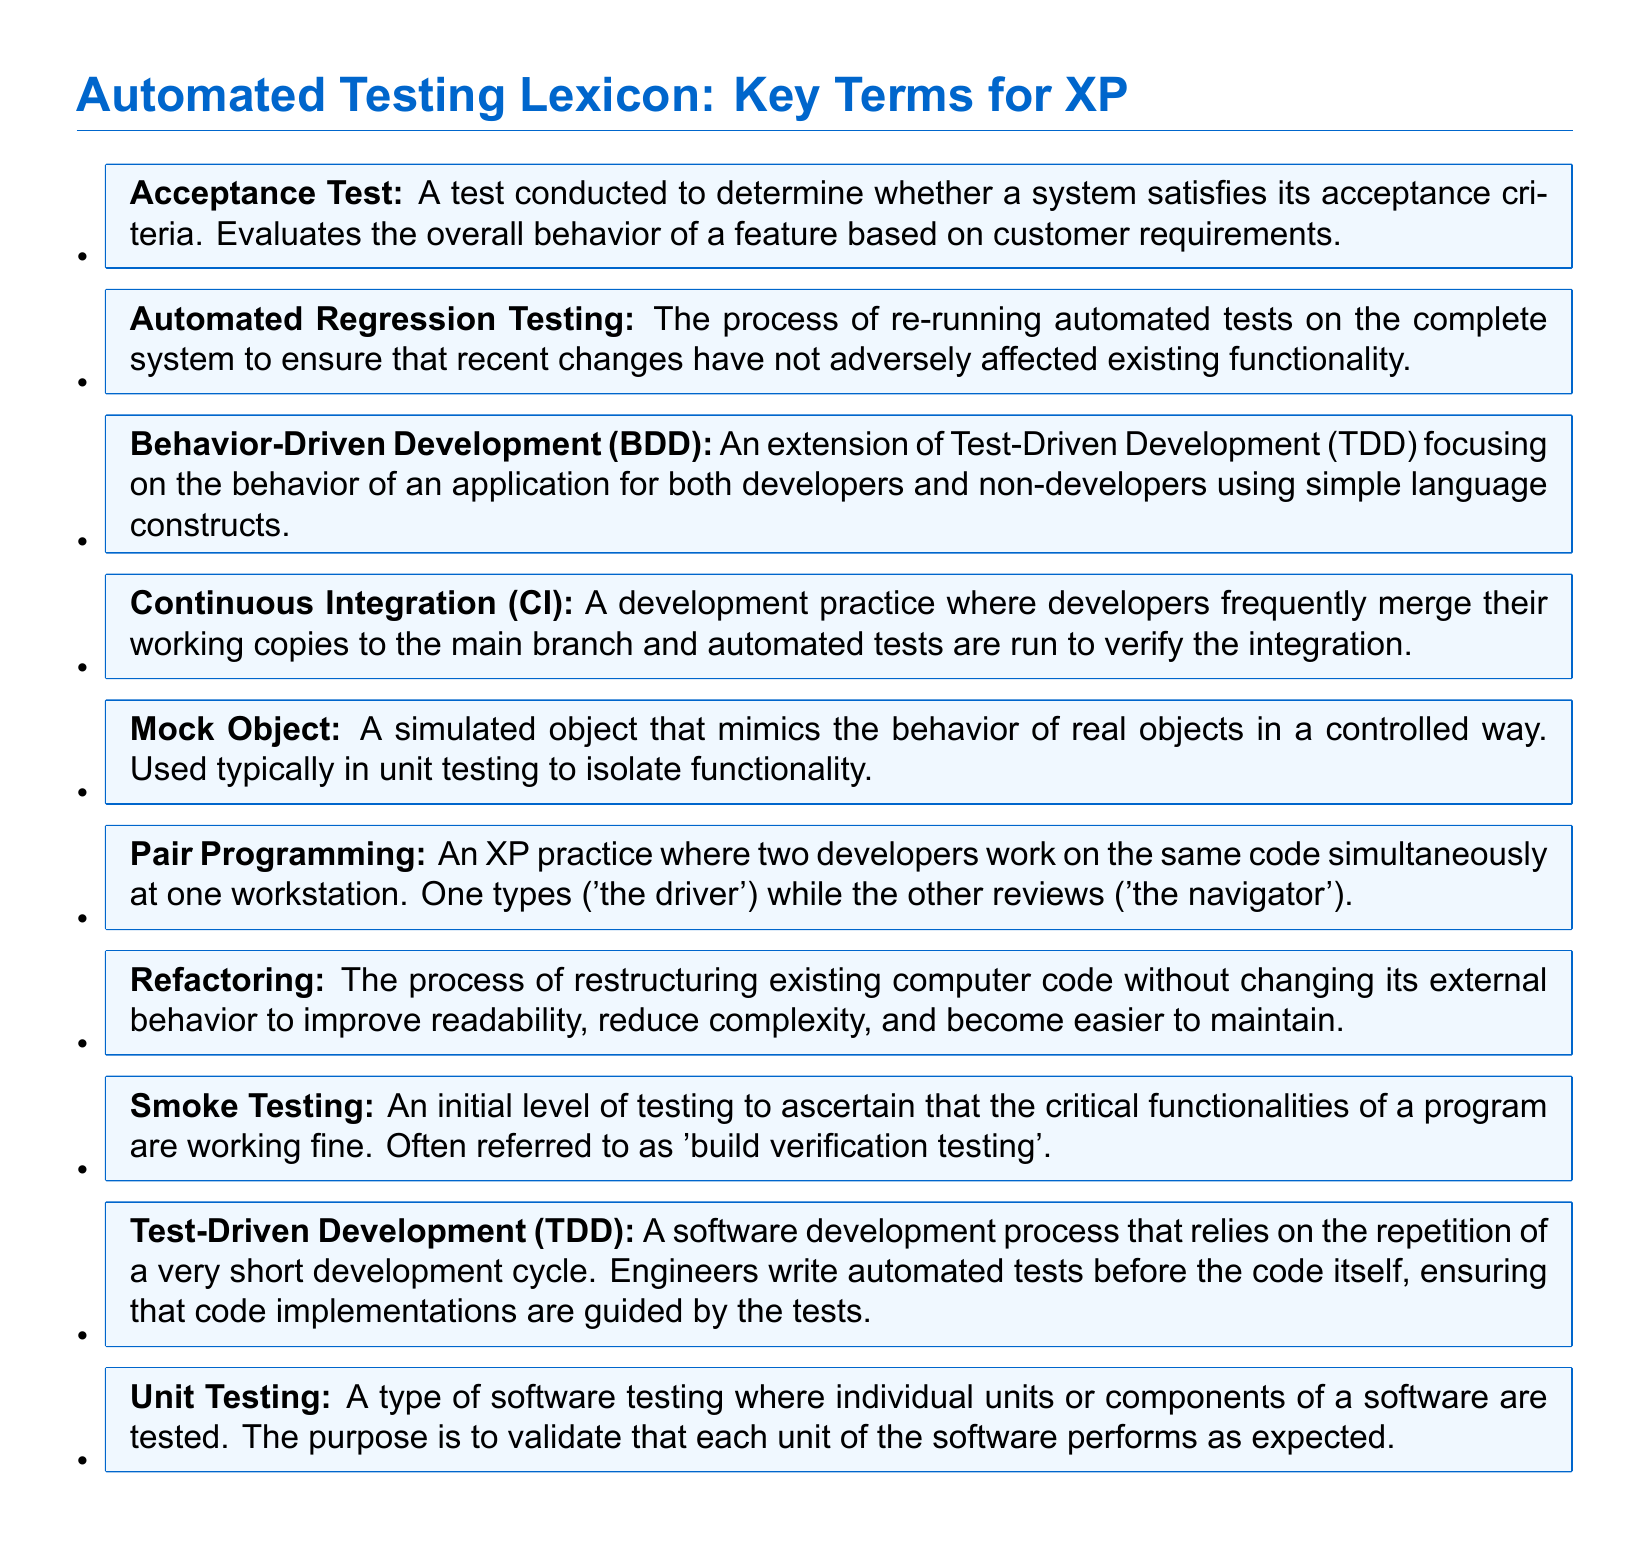What is the purpose of Acceptance Tests? Acceptance Tests determine whether a system satisfies its acceptance criteria and evaluates the overall behavior of a feature based on customer requirements.
Answer: To evaluate feature behavior What does CI stand for in the document? CI is a common abbreviation used in software development that stands for Continuous Integration.
Answer: Continuous Integration What type of testing does TDD rely on? TDD, or Test-Driven Development, relies on the repetition of a very short development cycle and writing automated tests before the code itself.
Answer: Automated tests What does a Mock Object do? A Mock Object mimics the behavior of real objects in a controlled way and is used in unit testing to isolate functionality.
Answer: Mimics real objects What is the initial level of testing referred to in the document? This level of testing is known as Smoke Testing, which verifies that critical functionalities are working fine.
Answer: Smoke Testing What should developers do during Pair Programming? Developers work on the same code simultaneously at one workstation, with one typing and the other reviewing.
Answer: Work together How does BDD extend TDD? Behavior-Driven Development (BDD) focuses on the behavior of an application for both developers and non-developers, using simple language constructs.
Answer: It focuses on application behavior What is the goal of Refactoring? The goal of Refactoring is to restructure existing code without changing its external behavior to improve readability and reduce complexity.
Answer: Improve readability What is the main function of Automated Regression Testing? The main function is to re-run automated tests on the complete system to ensure that recent changes have not adversely affected existing functionality.
Answer: Verify recent changes 